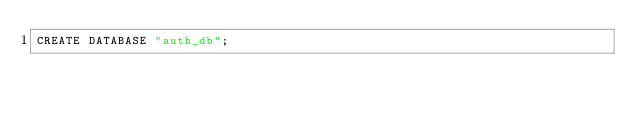Convert code to text. <code><loc_0><loc_0><loc_500><loc_500><_SQL_>CREATE DATABASE "auth_db";</code> 